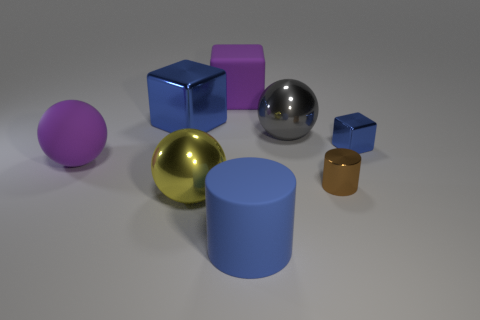Add 1 large metallic cubes. How many objects exist? 9 Subtract all cubes. How many objects are left? 5 Add 8 yellow things. How many yellow things are left? 9 Add 1 tiny yellow rubber cylinders. How many tiny yellow rubber cylinders exist? 1 Subtract 1 gray spheres. How many objects are left? 7 Subtract all big gray metal things. Subtract all big yellow spheres. How many objects are left? 6 